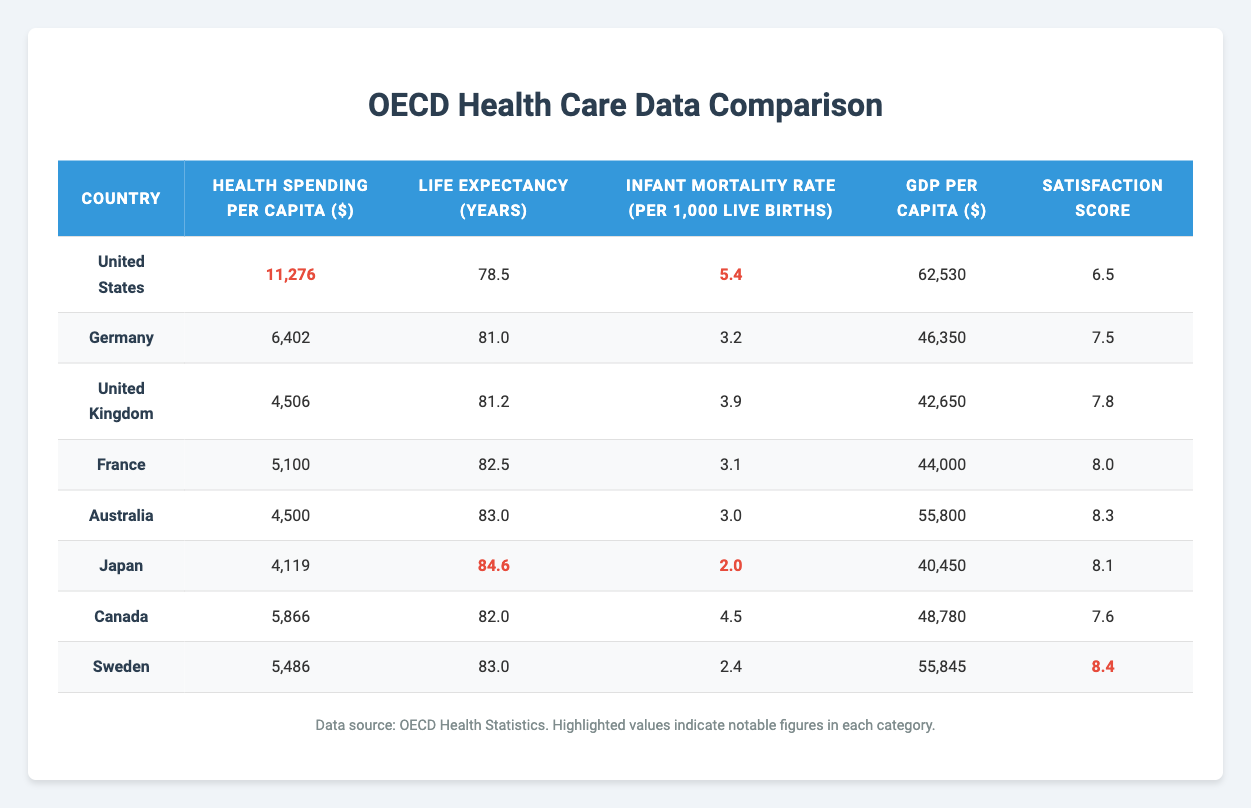What is the Health Spending Per Capita in the United States? The table shows that the Health Spending Per Capita for the United States is highlighted as 11,276.
Answer: 11,276 Which country has the highest Life Expectancy? The Life Expectancy values are listed in the table, and Japan has the highest value highlighted as 84.6 years.
Answer: 84.6 Is Germany's Infant Mortality Rate lower than that of the United States? Comparing the Infant Mortality Rates, Germany is at 3.2 while the United States is higher at 5.4, so Germany’s rate is lower.
Answer: Yes What is the difference in Life Expectancy between Japan and Canada? Japan's Life Expectancy is highlighted as 84.6 years, and Canada's is 82.0 years. The difference is 84.6 - 82.0 = 2.6 years.
Answer: 2.6 How much does Australia spend on health care per capita compared to the United Kingdom? Australia spends 4,500 while the United Kingdom spends 4,506. The difference is 4,506 - 4,500 = 6.
Answer: 6 Which country has a higher Satisfaction Score, France or Sweden? The Satisfaction Score for France is 8.0 and for Sweden it’s highlighted as 8.4. Since 8.4 is greater than 8.0, Sweden has a higher score.
Answer: Sweden What is the average GDP Per Capita among the listed countries? The GDP Per Capita values are 62,530 (USA), 46,350 (Germany), 42,650 (UK), 44,000 (France), 55,800 (Australia), 40,450 (Japan), 48,780 (Canada), and 55,845 (Sweden). Adding them gives a total of 392,605, and dividing by 8 gives an average of 49,075.625.
Answer: 49,075.63 Is Canada’s Health Spending Per Capita higher than that of Japan? Canada’s Health Spending is 5,866, while Japan’s is 4,119. Since 5,866 is greater than 4,119, it is higher.
Answer: Yes What is the relationship between Health Spending Per Capita and Life Expectancy in these countries? By looking at the trends in both columns, the United States has the highest spending but lower life expectancy, while Japan has lower spending with the highest life expectancy, indicating there’s not a straight correlation between spending and outcomes.
Answer: No direct correlation If we combine the Infant Mortality Rates of Australia, Japan, and Canada, what is the total? The Infant Mortality Rates for Australia (3.0), Japan (2.0), and Canada (4.5) add up to 3.0 + 2.0 + 4.5 = 9.5 per 1,000 live births.
Answer: 9.5 